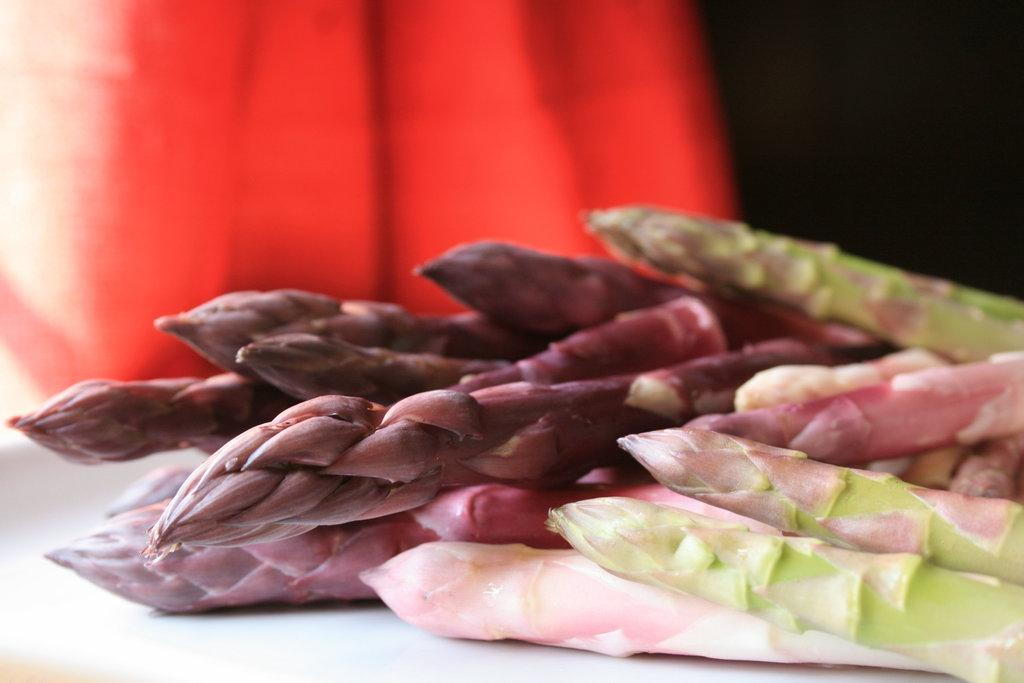What is present in the image? There are plants in the image. How would you describe the background of the image? The background of the image is blurred, and the background color is red. What type of fiction is the doctor reading in the image? There is no doctor or fiction present in the image; it only features plants and a blurred, red background. 